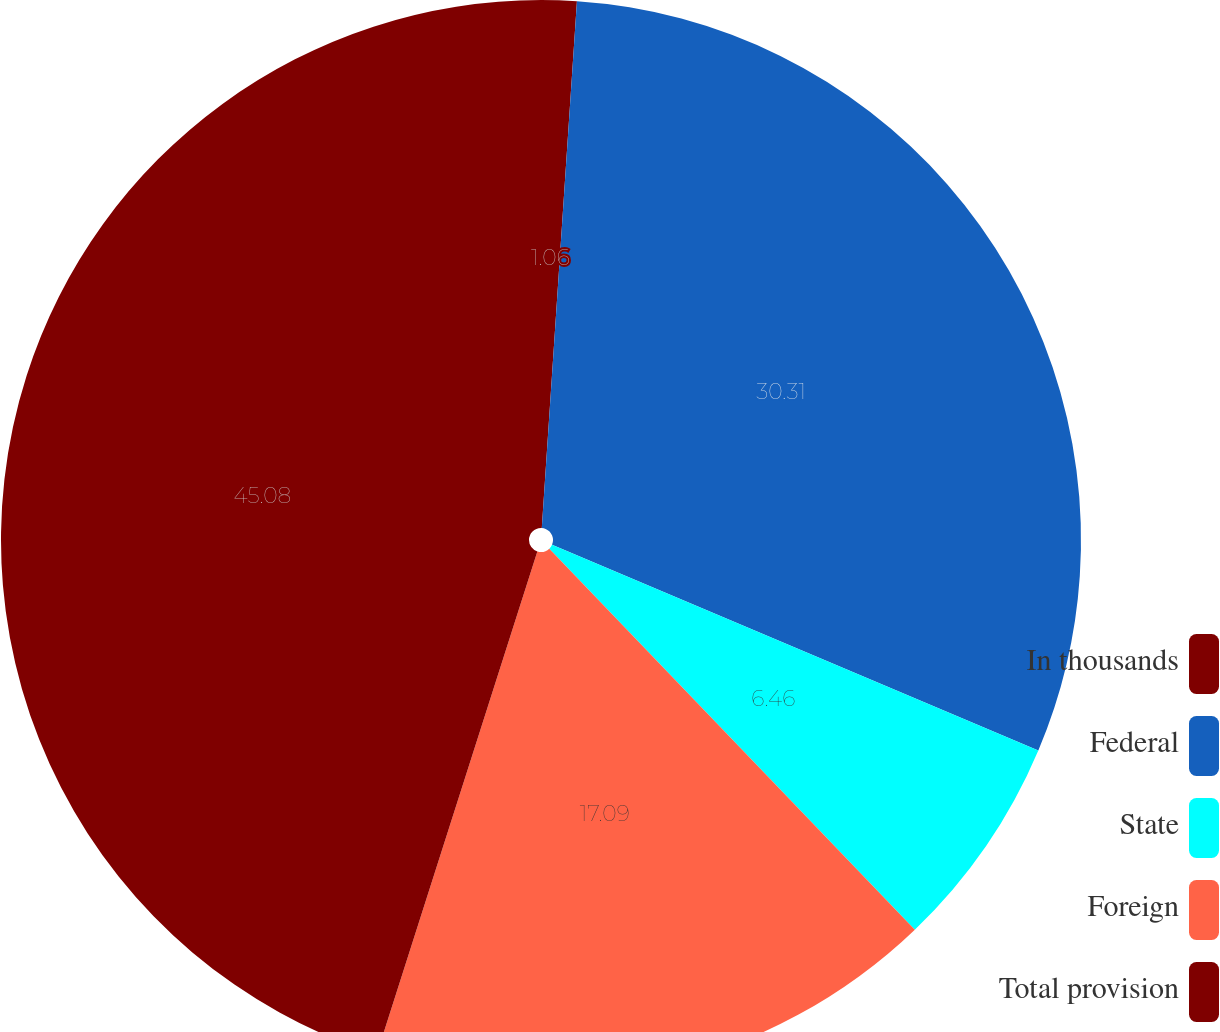Convert chart to OTSL. <chart><loc_0><loc_0><loc_500><loc_500><pie_chart><fcel>In thousands<fcel>Federal<fcel>State<fcel>Foreign<fcel>Total provision<nl><fcel>1.06%<fcel>30.31%<fcel>6.46%<fcel>17.09%<fcel>45.08%<nl></chart> 